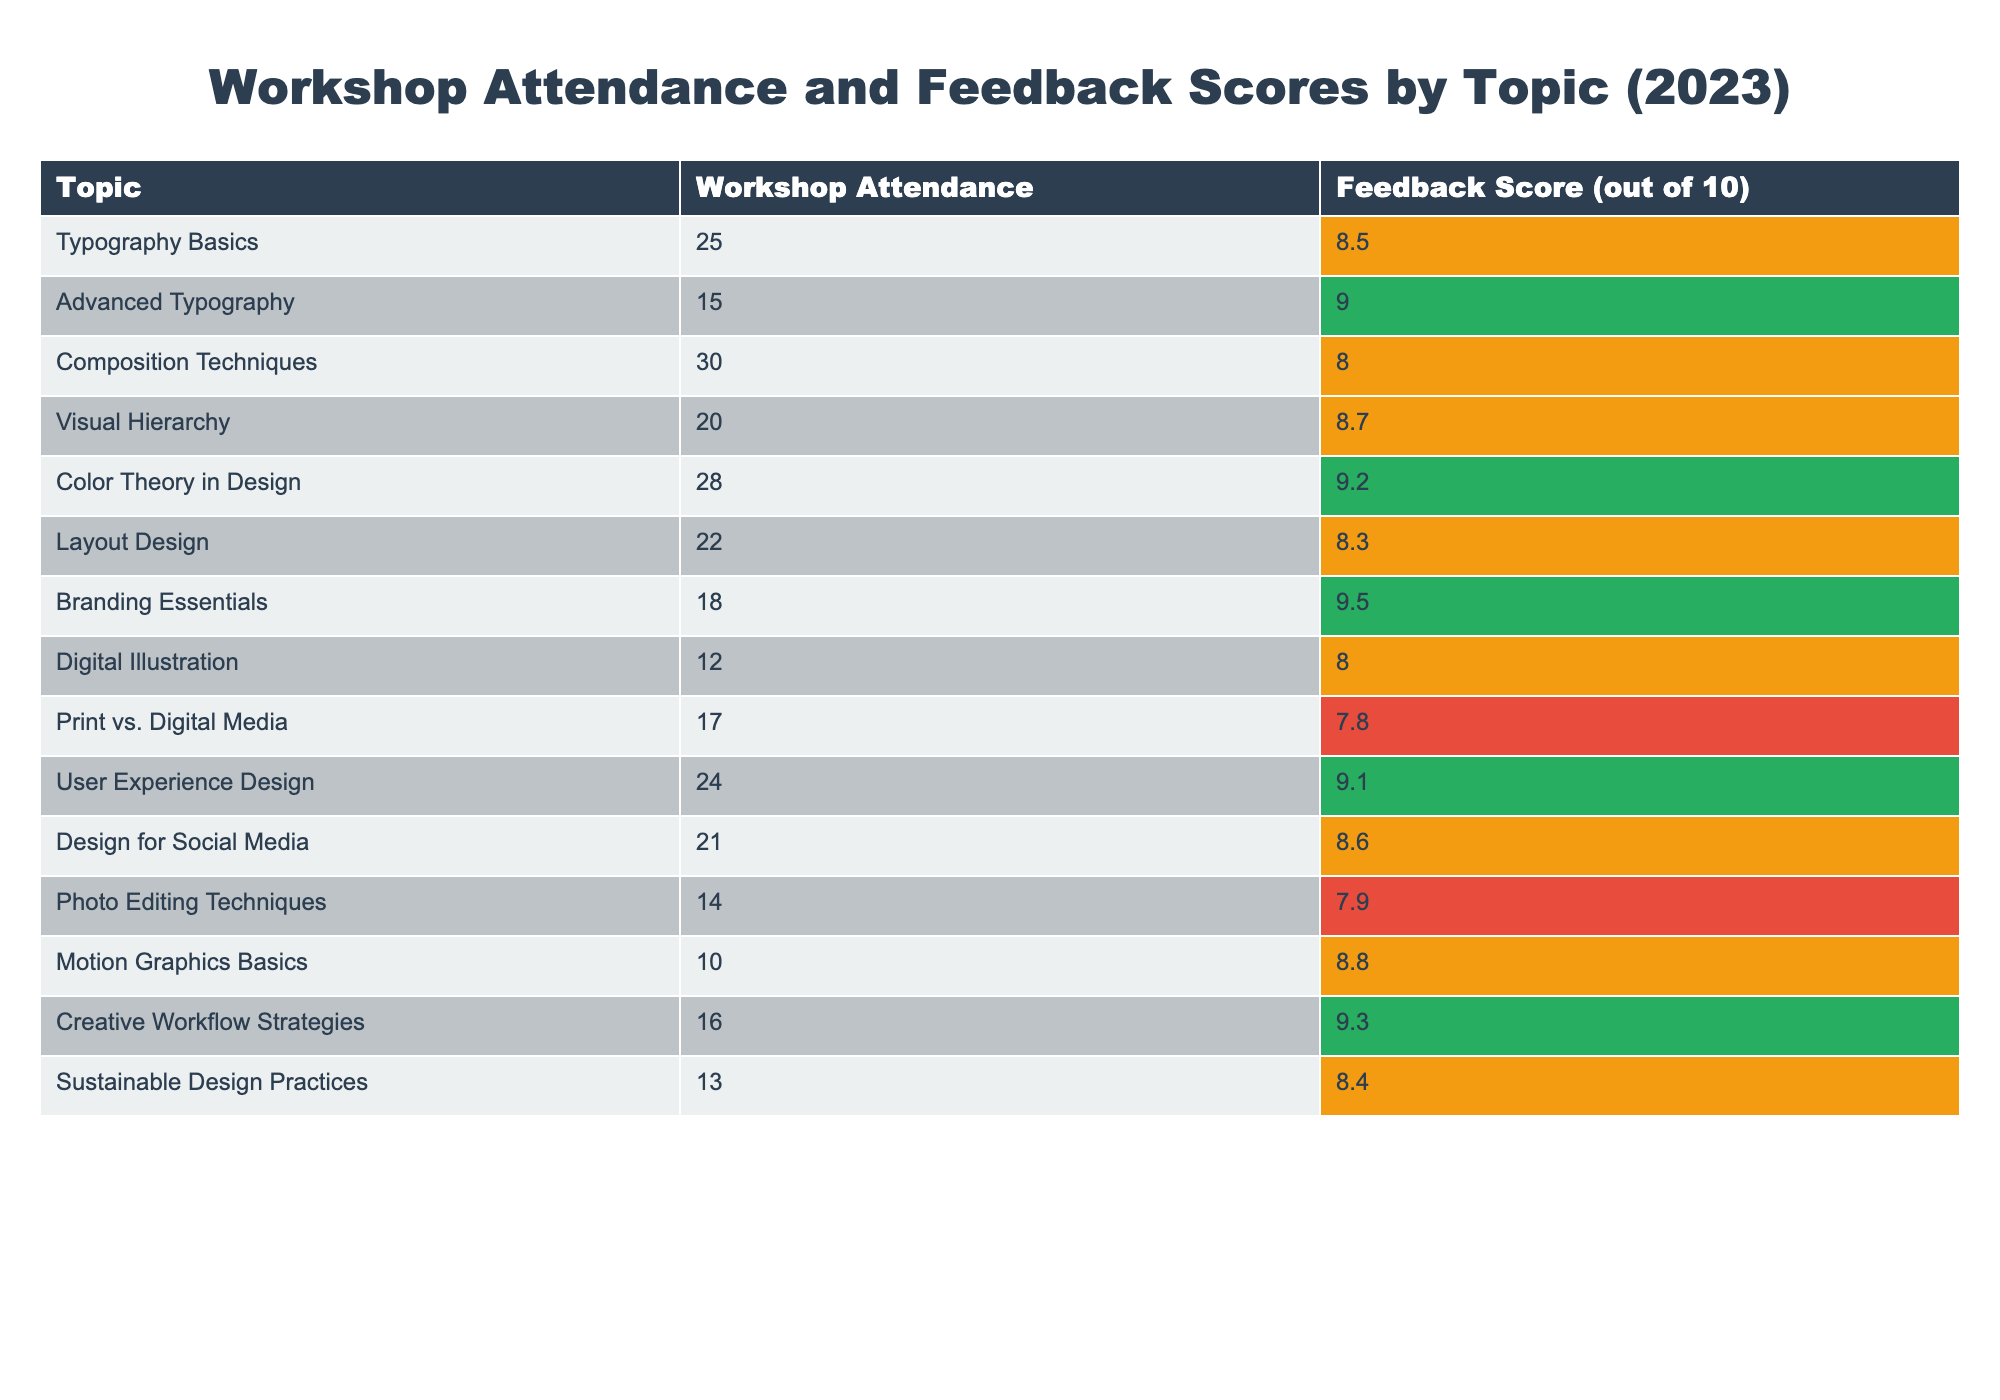What is the feedback score for 'Color Theory in Design'? The feedback score for 'Color Theory in Design' is listed in the table under the relevant column and is 9.2.
Answer: 9.2 Which workshop topic had the lowest attendance? Looking at the 'Workshop Attendance' column, 'Motion Graphics Basics' has the lowest attendance at 10.
Answer: Motion Graphics Basics What is the average feedback score for workshops with attendance greater than 20? To find the average feedback score for workshops with attendance greater than 20, we first identify those topics: Typography Basics (8.5), Composition Techniques (8.0), Color Theory in Design (9.2), User Experience Design (9.1), Design for Social Media (8.6). The sum of these scores is (8.5 + 8.0 + 9.2 + 9.1 + 8.6) = 43.4 and the count is 5, so the average is 43.4 / 5 = 8.68.
Answer: 8.68 Is the feedback score for 'Digital Illustration' greater than 8? The feedback score for 'Digital Illustration' is listed in the table as 8.0, which is not greater than 8.
Answer: No How many workshops had a feedback score of 9 or higher? By counting the workshops listed with a feedback score of 9 or higher from the 'Feedback Score' column: Advanced Typography (9.0), Color Theory in Design (9.2), Branding Essentials (9.5), User Experience Design (9.1), Creative Workflow Strategies (9.3). This gives a total of 5 workshops.
Answer: 5 What is the total attendance for all workshops grouped by a feedback score of less than 8? From the table, only 'Print vs. Digital Media' (17) and 'Photo Editing Techniques' (14) have feedback scores less than 8. Therefore, we sum those: 17 + 14 = 31.
Answer: 31 Which workshop had both high attendance and a high feedback score (greater than 9)? Checking both columns, the workshops that meet this criteria are Color Theory in Design (28, score 9.2) and Branding Essentials (18, score 9.5). Both workshops have high attendance (greater than 20) and high feedback scores.
Answer: Color Theory in Design, Branding Essentials What is the difference in attendance between 'Typography Basics' and 'Motion Graphics Basics'? 'Typography Basics' has an attendance of 25 while 'Motion Graphics Basics' has 10. The difference is 25 - 10 = 15.
Answer: 15 